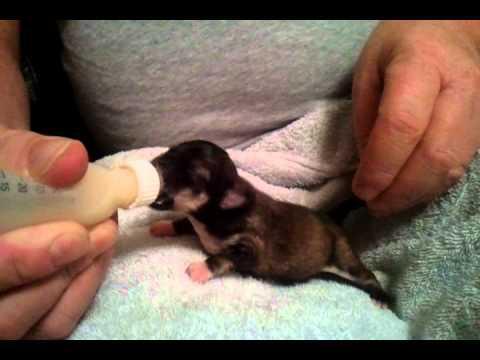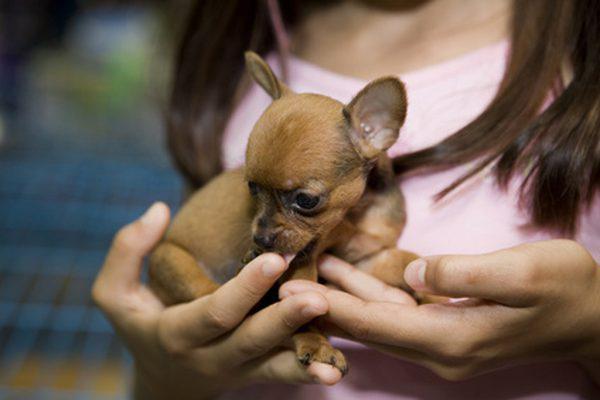The first image is the image on the left, the second image is the image on the right. For the images displayed, is the sentence "At least one image shows a tiny puppy with closed eyes, held in the palm of a hand." factually correct? Answer yes or no. No. The first image is the image on the left, the second image is the image on the right. For the images displayed, is the sentence "Someone is holding at least one of the animals in all of the images." factually correct? Answer yes or no. Yes. 